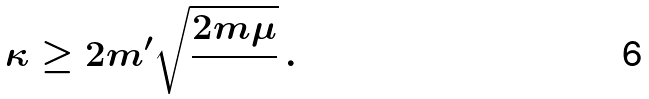Convert formula to latex. <formula><loc_0><loc_0><loc_500><loc_500>\kappa \geq 2 m ^ { \prime } \sqrt { \frac { 2 m \mu } { } } \, .</formula> 